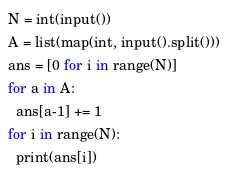<code> <loc_0><loc_0><loc_500><loc_500><_Python_>N = int(input())
A = list(map(int, input().split()))
ans = [0 for i in range(N)]
for a in A:
  ans[a-1] += 1
for i in range(N):
  print(ans[i])</code> 